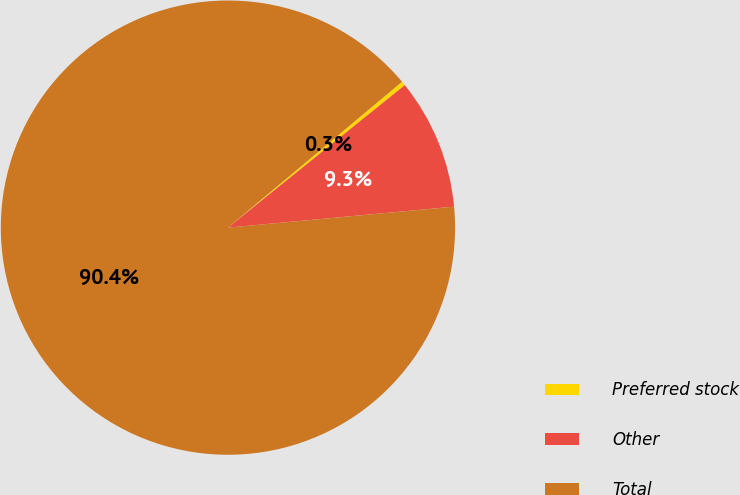Convert chart. <chart><loc_0><loc_0><loc_500><loc_500><pie_chart><fcel>Preferred stock<fcel>Other<fcel>Total<nl><fcel>0.31%<fcel>9.32%<fcel>90.38%<nl></chart> 